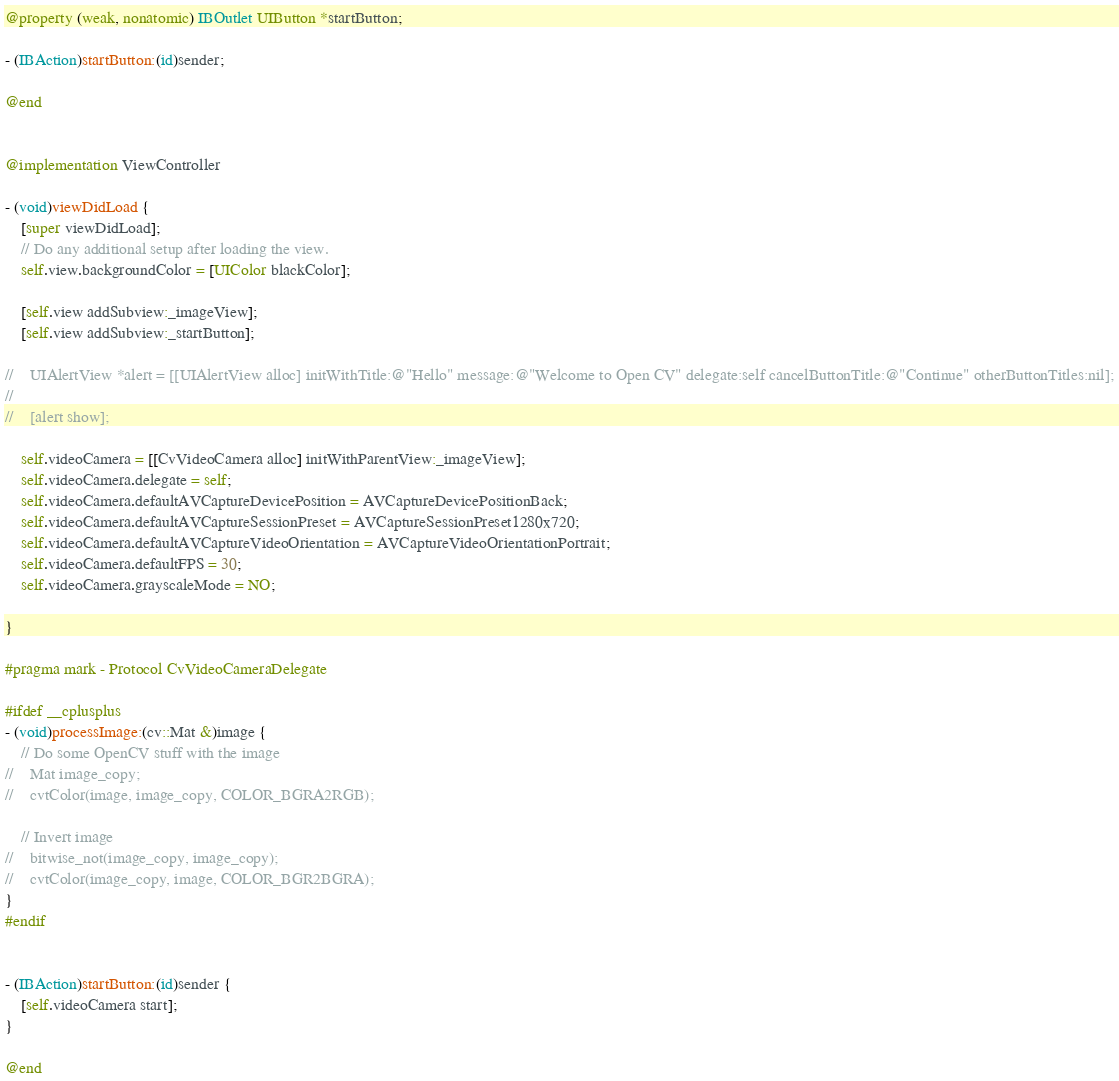Convert code to text. <code><loc_0><loc_0><loc_500><loc_500><_ObjectiveC_>
@property (weak, nonatomic) IBOutlet UIButton *startButton;

- (IBAction)startButton:(id)sender;

@end


@implementation ViewController

- (void)viewDidLoad {
    [super viewDidLoad];
    // Do any additional setup after loading the view.
    self.view.backgroundColor = [UIColor blackColor];
    
    [self.view addSubview:_imageView];
    [self.view addSubview:_startButton];
    
//    UIAlertView *alert = [[UIAlertView alloc] initWithTitle:@"Hello" message:@"Welcome to Open CV" delegate:self cancelButtonTitle:@"Continue" otherButtonTitles:nil];
//
//    [alert show];
    
    self.videoCamera = [[CvVideoCamera alloc] initWithParentView:_imageView];
    self.videoCamera.delegate = self;
    self.videoCamera.defaultAVCaptureDevicePosition = AVCaptureDevicePositionBack;
    self.videoCamera.defaultAVCaptureSessionPreset = AVCaptureSessionPreset1280x720;
    self.videoCamera.defaultAVCaptureVideoOrientation = AVCaptureVideoOrientationPortrait;
    self.videoCamera.defaultFPS = 30;
    self.videoCamera.grayscaleMode = NO;

}

#pragma mark - Protocol CvVideoCameraDelegate

#ifdef __cplusplus
- (void)processImage:(cv::Mat &)image {
    // Do some OpenCV stuff with the image
//    Mat image_copy;
//    cvtColor(image, image_copy, COLOR_BGRA2RGB);
    
    // Invert image
//    bitwise_not(image_copy, image_copy);
//    cvtColor(image_copy, image, COLOR_BGR2BGRA);
}
#endif


- (IBAction)startButton:(id)sender {
    [self.videoCamera start];
}

@end
</code> 